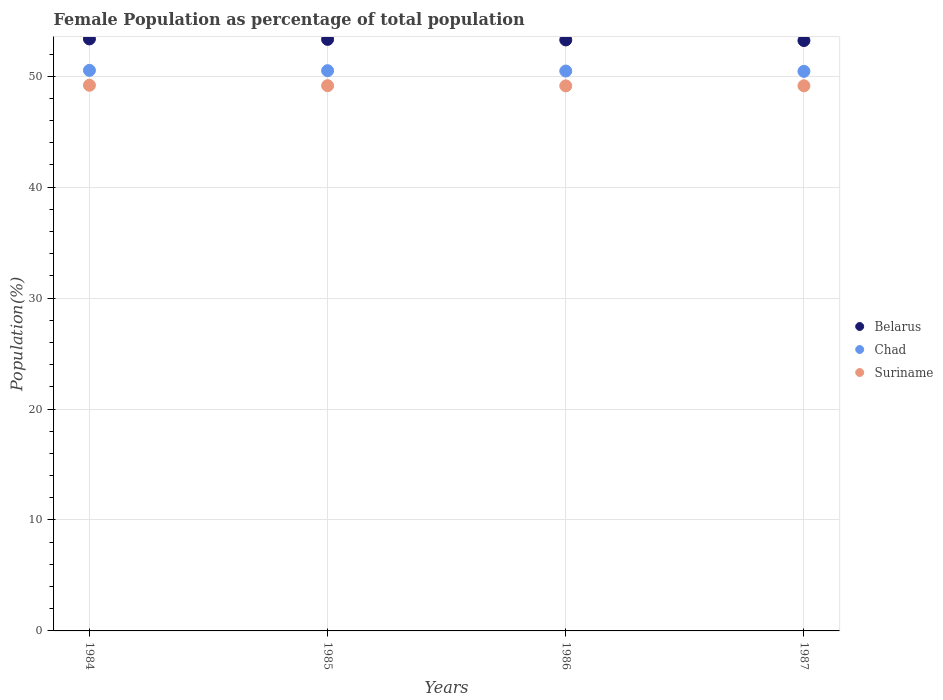How many different coloured dotlines are there?
Make the answer very short. 3. Is the number of dotlines equal to the number of legend labels?
Keep it short and to the point. Yes. What is the female population in in Belarus in 1985?
Ensure brevity in your answer.  53.32. Across all years, what is the maximum female population in in Chad?
Give a very brief answer. 50.53. Across all years, what is the minimum female population in in Belarus?
Your answer should be compact. 53.22. In which year was the female population in in Suriname maximum?
Ensure brevity in your answer.  1984. What is the total female population in in Suriname in the graph?
Give a very brief answer. 196.6. What is the difference between the female population in in Suriname in 1984 and that in 1987?
Give a very brief answer. 0.05. What is the difference between the female population in in Chad in 1986 and the female population in in Belarus in 1987?
Keep it short and to the point. -2.75. What is the average female population in in Belarus per year?
Offer a very short reply. 53.29. In the year 1986, what is the difference between the female population in in Chad and female population in in Suriname?
Provide a succinct answer. 1.34. What is the ratio of the female population in in Suriname in 1985 to that in 1987?
Offer a terse response. 1. What is the difference between the highest and the second highest female population in in Belarus?
Offer a very short reply. 0.04. What is the difference between the highest and the lowest female population in in Belarus?
Make the answer very short. 0.15. Is it the case that in every year, the sum of the female population in in Belarus and female population in in Chad  is greater than the female population in in Suriname?
Provide a succinct answer. Yes. Does the female population in in Belarus monotonically increase over the years?
Give a very brief answer. No. Is the female population in in Chad strictly greater than the female population in in Belarus over the years?
Make the answer very short. No. Is the female population in in Chad strictly less than the female population in in Suriname over the years?
Offer a very short reply. No. Does the graph contain any zero values?
Provide a succinct answer. No. How are the legend labels stacked?
Provide a succinct answer. Vertical. What is the title of the graph?
Ensure brevity in your answer.  Female Population as percentage of total population. What is the label or title of the X-axis?
Provide a succinct answer. Years. What is the label or title of the Y-axis?
Ensure brevity in your answer.  Population(%). What is the Population(%) of Belarus in 1984?
Give a very brief answer. 53.36. What is the Population(%) in Chad in 1984?
Make the answer very short. 50.53. What is the Population(%) of Suriname in 1984?
Your response must be concise. 49.19. What is the Population(%) of Belarus in 1985?
Make the answer very short. 53.32. What is the Population(%) in Chad in 1985?
Offer a terse response. 50.5. What is the Population(%) of Suriname in 1985?
Give a very brief answer. 49.15. What is the Population(%) of Belarus in 1986?
Keep it short and to the point. 53.27. What is the Population(%) of Chad in 1986?
Your answer should be compact. 50.47. What is the Population(%) in Suriname in 1986?
Your answer should be very brief. 49.13. What is the Population(%) of Belarus in 1987?
Your answer should be compact. 53.22. What is the Population(%) in Chad in 1987?
Your response must be concise. 50.44. What is the Population(%) in Suriname in 1987?
Keep it short and to the point. 49.14. Across all years, what is the maximum Population(%) in Belarus?
Provide a succinct answer. 53.36. Across all years, what is the maximum Population(%) in Chad?
Ensure brevity in your answer.  50.53. Across all years, what is the maximum Population(%) in Suriname?
Give a very brief answer. 49.19. Across all years, what is the minimum Population(%) of Belarus?
Ensure brevity in your answer.  53.22. Across all years, what is the minimum Population(%) in Chad?
Offer a terse response. 50.44. Across all years, what is the minimum Population(%) in Suriname?
Offer a very short reply. 49.13. What is the total Population(%) in Belarus in the graph?
Provide a succinct answer. 213.17. What is the total Population(%) in Chad in the graph?
Your answer should be very brief. 201.94. What is the total Population(%) in Suriname in the graph?
Ensure brevity in your answer.  196.6. What is the difference between the Population(%) in Belarus in 1984 and that in 1985?
Provide a succinct answer. 0.04. What is the difference between the Population(%) in Chad in 1984 and that in 1985?
Ensure brevity in your answer.  0.03. What is the difference between the Population(%) of Suriname in 1984 and that in 1985?
Keep it short and to the point. 0.04. What is the difference between the Population(%) in Belarus in 1984 and that in 1986?
Your response must be concise. 0.09. What is the difference between the Population(%) of Chad in 1984 and that in 1986?
Provide a short and direct response. 0.06. What is the difference between the Population(%) in Suriname in 1984 and that in 1986?
Ensure brevity in your answer.  0.06. What is the difference between the Population(%) in Belarus in 1984 and that in 1987?
Provide a short and direct response. 0.15. What is the difference between the Population(%) in Chad in 1984 and that in 1987?
Provide a short and direct response. 0.09. What is the difference between the Population(%) of Suriname in 1984 and that in 1987?
Ensure brevity in your answer.  0.05. What is the difference between the Population(%) in Belarus in 1985 and that in 1986?
Your response must be concise. 0.05. What is the difference between the Population(%) in Chad in 1985 and that in 1986?
Provide a short and direct response. 0.03. What is the difference between the Population(%) of Suriname in 1985 and that in 1986?
Your answer should be very brief. 0.02. What is the difference between the Population(%) in Belarus in 1985 and that in 1987?
Your answer should be compact. 0.1. What is the difference between the Population(%) of Chad in 1985 and that in 1987?
Keep it short and to the point. 0.06. What is the difference between the Population(%) of Suriname in 1985 and that in 1987?
Your answer should be compact. 0.01. What is the difference between the Population(%) of Belarus in 1986 and that in 1987?
Provide a short and direct response. 0.06. What is the difference between the Population(%) of Chad in 1986 and that in 1987?
Provide a short and direct response. 0.03. What is the difference between the Population(%) of Suriname in 1986 and that in 1987?
Offer a terse response. -0.01. What is the difference between the Population(%) of Belarus in 1984 and the Population(%) of Chad in 1985?
Ensure brevity in your answer.  2.86. What is the difference between the Population(%) in Belarus in 1984 and the Population(%) in Suriname in 1985?
Keep it short and to the point. 4.22. What is the difference between the Population(%) of Chad in 1984 and the Population(%) of Suriname in 1985?
Ensure brevity in your answer.  1.38. What is the difference between the Population(%) of Belarus in 1984 and the Population(%) of Chad in 1986?
Offer a very short reply. 2.89. What is the difference between the Population(%) of Belarus in 1984 and the Population(%) of Suriname in 1986?
Your answer should be compact. 4.23. What is the difference between the Population(%) of Chad in 1984 and the Population(%) of Suriname in 1986?
Your answer should be very brief. 1.4. What is the difference between the Population(%) in Belarus in 1984 and the Population(%) in Chad in 1987?
Provide a short and direct response. 2.92. What is the difference between the Population(%) of Belarus in 1984 and the Population(%) of Suriname in 1987?
Your answer should be very brief. 4.23. What is the difference between the Population(%) in Chad in 1984 and the Population(%) in Suriname in 1987?
Offer a very short reply. 1.39. What is the difference between the Population(%) of Belarus in 1985 and the Population(%) of Chad in 1986?
Give a very brief answer. 2.85. What is the difference between the Population(%) of Belarus in 1985 and the Population(%) of Suriname in 1986?
Offer a terse response. 4.19. What is the difference between the Population(%) in Chad in 1985 and the Population(%) in Suriname in 1986?
Your answer should be compact. 1.37. What is the difference between the Population(%) of Belarus in 1985 and the Population(%) of Chad in 1987?
Provide a succinct answer. 2.88. What is the difference between the Population(%) of Belarus in 1985 and the Population(%) of Suriname in 1987?
Offer a terse response. 4.18. What is the difference between the Population(%) of Chad in 1985 and the Population(%) of Suriname in 1987?
Provide a succinct answer. 1.36. What is the difference between the Population(%) of Belarus in 1986 and the Population(%) of Chad in 1987?
Make the answer very short. 2.83. What is the difference between the Population(%) of Belarus in 1986 and the Population(%) of Suriname in 1987?
Offer a very short reply. 4.14. What is the difference between the Population(%) of Chad in 1986 and the Population(%) of Suriname in 1987?
Give a very brief answer. 1.33. What is the average Population(%) of Belarus per year?
Provide a short and direct response. 53.29. What is the average Population(%) of Chad per year?
Make the answer very short. 50.48. What is the average Population(%) of Suriname per year?
Provide a short and direct response. 49.15. In the year 1984, what is the difference between the Population(%) in Belarus and Population(%) in Chad?
Your response must be concise. 2.83. In the year 1984, what is the difference between the Population(%) of Belarus and Population(%) of Suriname?
Keep it short and to the point. 4.18. In the year 1984, what is the difference between the Population(%) in Chad and Population(%) in Suriname?
Provide a succinct answer. 1.34. In the year 1985, what is the difference between the Population(%) in Belarus and Population(%) in Chad?
Make the answer very short. 2.82. In the year 1985, what is the difference between the Population(%) of Belarus and Population(%) of Suriname?
Your answer should be very brief. 4.17. In the year 1985, what is the difference between the Population(%) in Chad and Population(%) in Suriname?
Make the answer very short. 1.35. In the year 1986, what is the difference between the Population(%) in Belarus and Population(%) in Chad?
Ensure brevity in your answer.  2.8. In the year 1986, what is the difference between the Population(%) of Belarus and Population(%) of Suriname?
Your response must be concise. 4.14. In the year 1986, what is the difference between the Population(%) of Chad and Population(%) of Suriname?
Your answer should be very brief. 1.34. In the year 1987, what is the difference between the Population(%) of Belarus and Population(%) of Chad?
Offer a terse response. 2.78. In the year 1987, what is the difference between the Population(%) in Belarus and Population(%) in Suriname?
Make the answer very short. 4.08. In the year 1987, what is the difference between the Population(%) in Chad and Population(%) in Suriname?
Your answer should be compact. 1.3. What is the ratio of the Population(%) in Suriname in 1984 to that in 1985?
Your answer should be very brief. 1. What is the ratio of the Population(%) in Chad in 1984 to that in 1987?
Offer a terse response. 1. What is the ratio of the Population(%) of Suriname in 1984 to that in 1987?
Keep it short and to the point. 1. What is the ratio of the Population(%) of Belarus in 1985 to that in 1986?
Offer a terse response. 1. What is the ratio of the Population(%) in Suriname in 1985 to that in 1986?
Provide a succinct answer. 1. What is the ratio of the Population(%) of Belarus in 1985 to that in 1987?
Your response must be concise. 1. What is the ratio of the Population(%) in Chad in 1985 to that in 1987?
Offer a terse response. 1. What is the ratio of the Population(%) in Belarus in 1986 to that in 1987?
Provide a short and direct response. 1. What is the ratio of the Population(%) in Chad in 1986 to that in 1987?
Ensure brevity in your answer.  1. What is the ratio of the Population(%) of Suriname in 1986 to that in 1987?
Provide a short and direct response. 1. What is the difference between the highest and the second highest Population(%) of Belarus?
Provide a succinct answer. 0.04. What is the difference between the highest and the second highest Population(%) of Chad?
Ensure brevity in your answer.  0.03. What is the difference between the highest and the second highest Population(%) of Suriname?
Provide a succinct answer. 0.04. What is the difference between the highest and the lowest Population(%) of Belarus?
Offer a very short reply. 0.15. What is the difference between the highest and the lowest Population(%) in Chad?
Your answer should be very brief. 0.09. What is the difference between the highest and the lowest Population(%) in Suriname?
Provide a succinct answer. 0.06. 